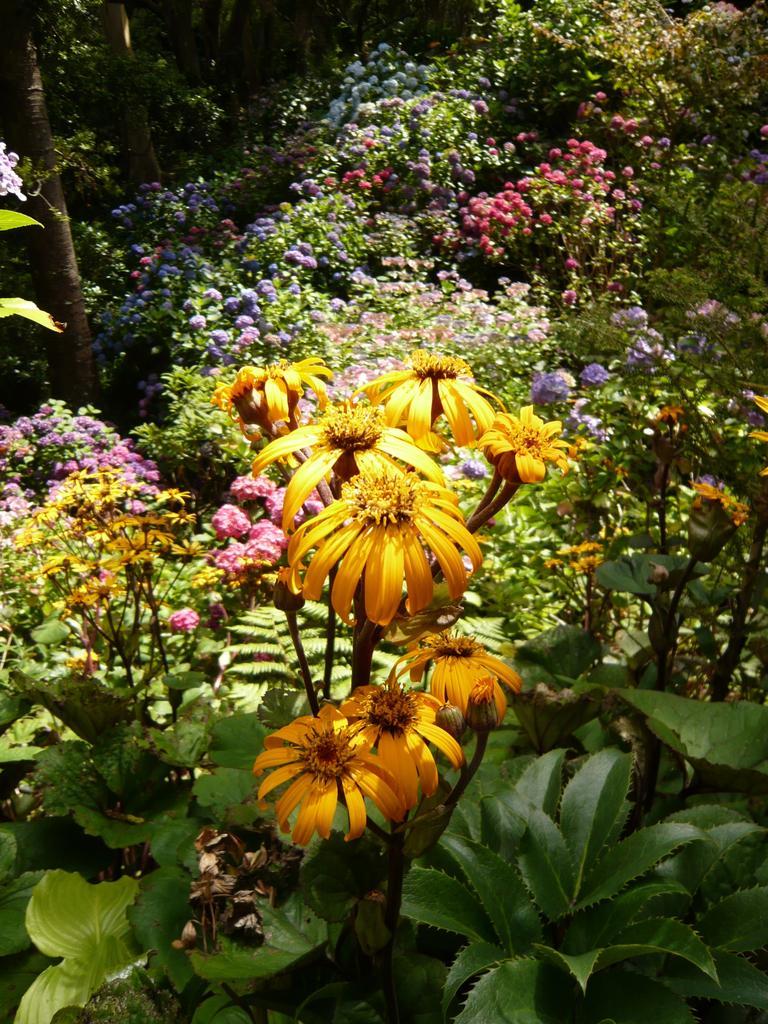Can you describe this image briefly? As we can see in the image there are plants and different colors of flowers. 